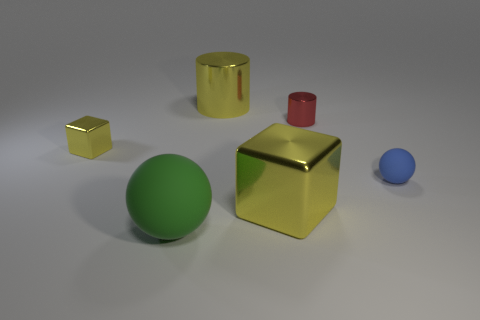What shapes are visible in the image? The image depicts several shapes, including a sphere, cubes, and cylinders. Which is the largest object in the image? The largest object appears to be the gold cube in the center of the image. 